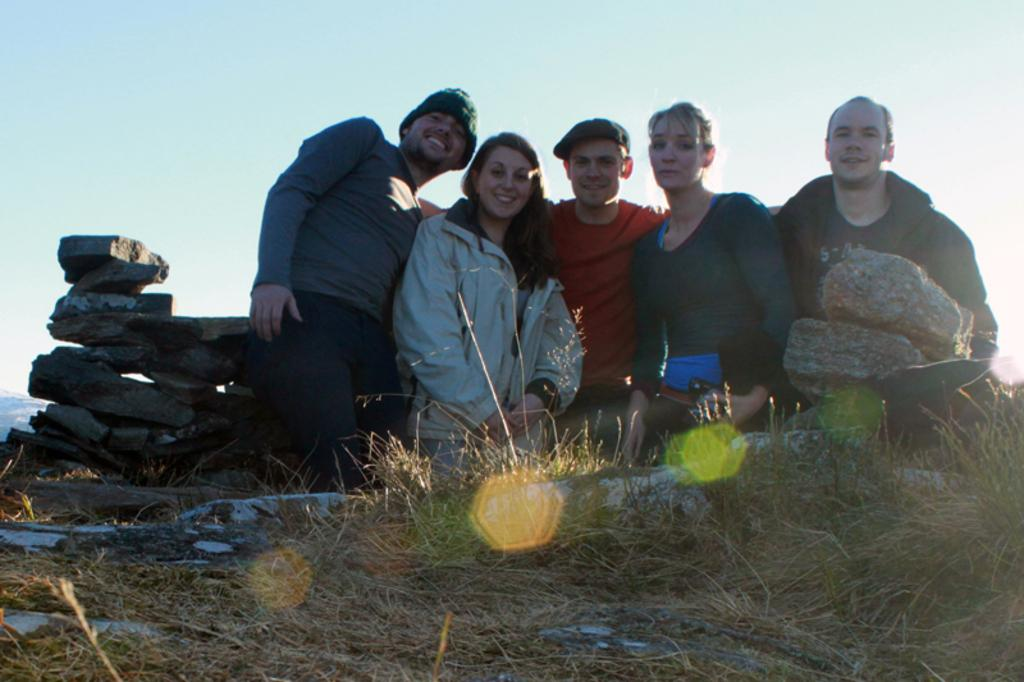What are the people in the image doing? The people in the image are standing. How can you describe the clothing of the people in the image? The people are wearing different color dresses. What type of vegetation is present in the image? There is dry grass in the image. What other objects can be seen in the image? There are stones in the image. What is the color of the sky in the image? The sky is white and blue in color. Can you tell me how many basketballs are lying on the dry grass in the image? There are no basketballs present in the image; it features people standing and stones on dry grass. What type of cars can be seen driving through the white and blue sky in the image? There are no cars visible in the image, and the sky is not a road for vehicles to drive on. 